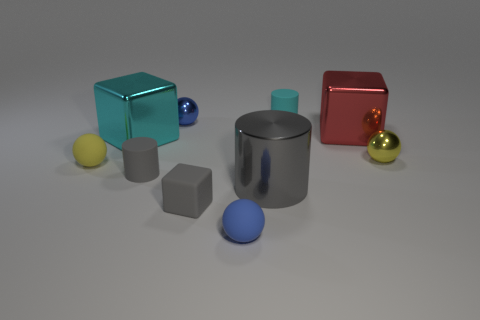Does the big object on the right side of the cyan matte thing have the same material as the small blue thing in front of the small blue shiny ball?
Provide a succinct answer. No. What is the color of the other rubber cylinder that is the same size as the gray rubber cylinder?
Keep it short and to the point. Cyan. There is a metal thing in front of the sphere that is right of the gray metallic cylinder behind the gray matte block; how big is it?
Offer a very short reply. Large. There is a ball that is both on the right side of the large cyan cube and in front of the yellow shiny thing; what is its color?
Your answer should be very brief. Blue. There is a rubber ball that is on the right side of the tiny yellow matte thing; what size is it?
Offer a very short reply. Small. What number of cylinders are the same material as the big red block?
Offer a very short reply. 1. What shape is the large metallic thing that is the same color as the small cube?
Your answer should be very brief. Cylinder. There is a cyan thing in front of the cyan cylinder; is it the same shape as the large red metal thing?
Offer a terse response. Yes. The large cylinder that is made of the same material as the red object is what color?
Provide a short and direct response. Gray. Is there a metal thing on the right side of the tiny rubber cylinder in front of the blue object behind the gray metal cylinder?
Your response must be concise. Yes. 